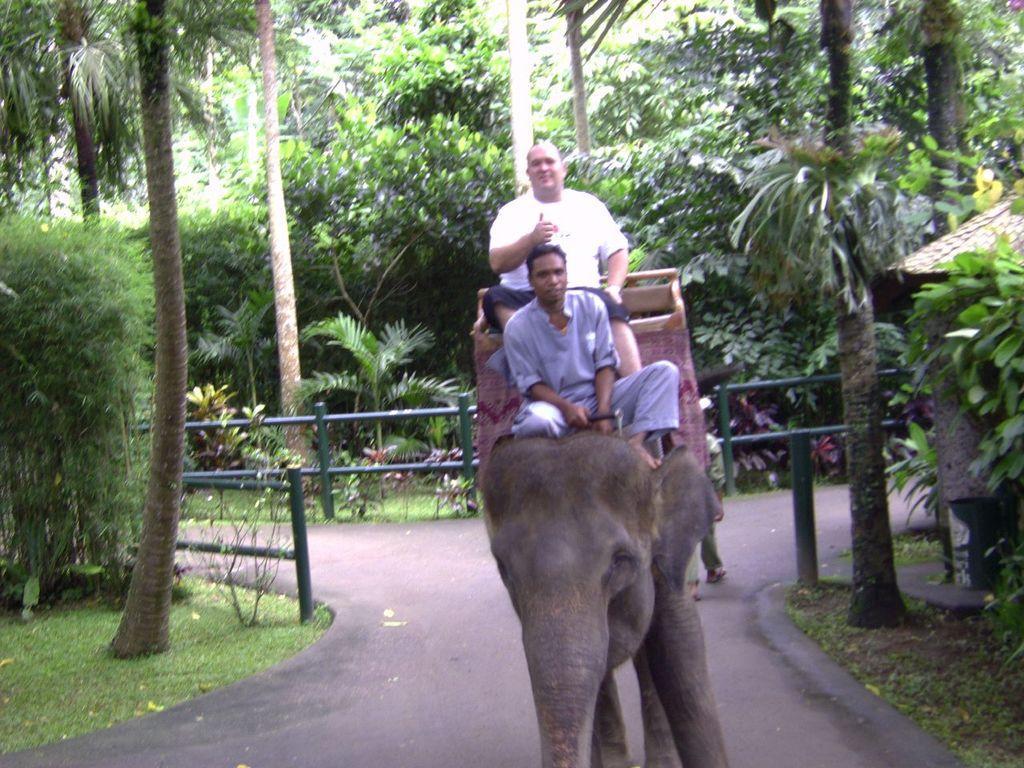How many people are in the image? There are two persons in the image. What are the two persons doing in the image? The two persons are sitting on an elephant. What can be seen in the background of the image? There are trees and plants in the background of the image. What type of barrier is present in the image? There is a fence in the image. What is the color of the grass in the image? The grass is green in color. What type of drug is being processed in the image? There is no reference to any drug or process in the image; it features two persons sitting on an elephant with a background of trees and plants, a fence, and green grass. 